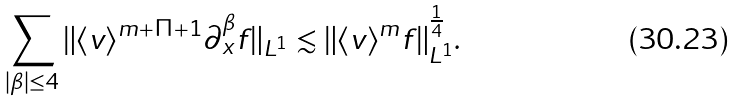Convert formula to latex. <formula><loc_0><loc_0><loc_500><loc_500>\sum _ { | \beta | \leq 4 } \| \langle v \rangle ^ { m + \Pi + 1 } \partial _ { x } ^ { \beta } f \| _ { L ^ { 1 } } \lesssim \| \langle v \rangle ^ { m } f \| _ { L ^ { 1 } } ^ { \frac { 1 } { 4 } } .</formula> 